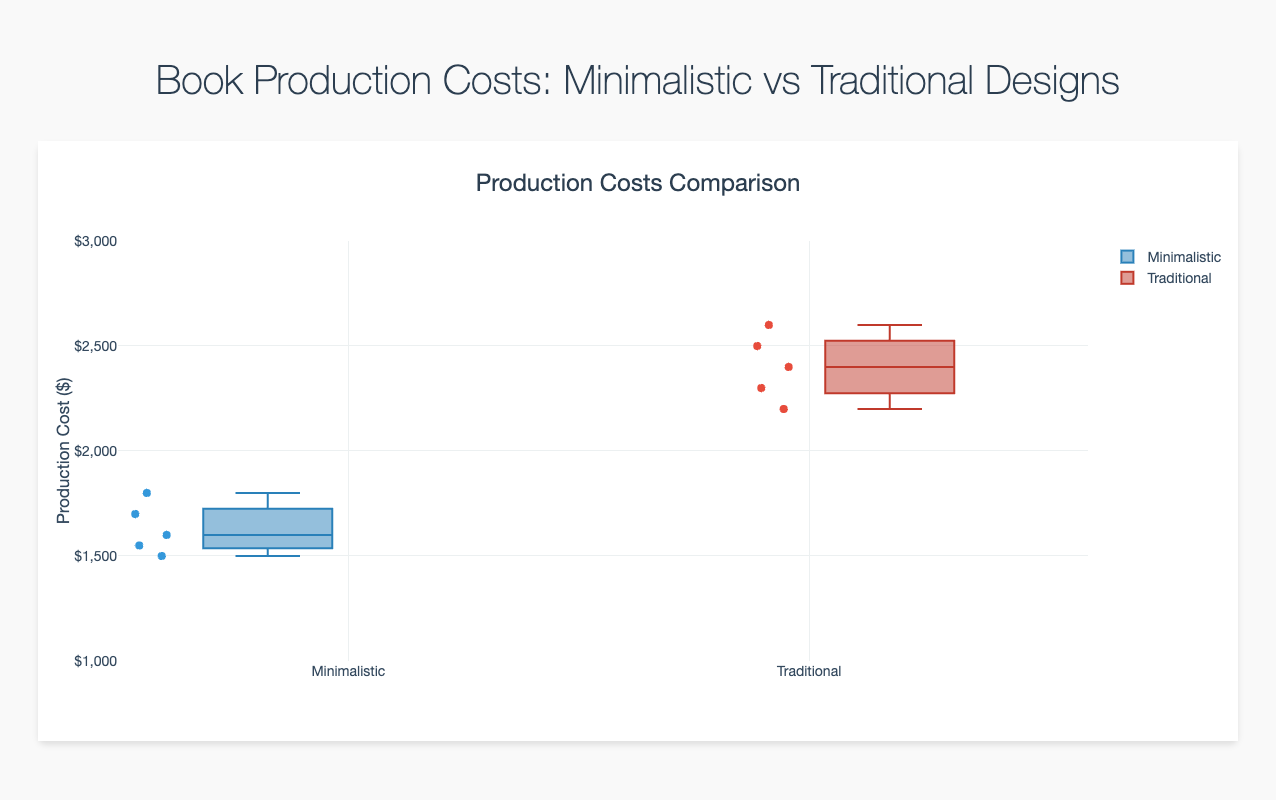What's the median production cost for books with minimalistic cover designs? The median value is the middle value when data points are arranged in ascending order. Arrange the minimalistic costs (1500, 1550, 1600, 1700, 1800), and the middle value is 1600.
Answer: 1600 Which design style has a higher maximum production cost? Look at the highest points of the whiskers for both box plots. The highest point for minimalistic is 1800, and for traditional, it is 2600.
Answer: Traditional How many data points are there for books with minimalistic cover designs? Count the number of points present in the "Minimalistic" box plot. There are 5 points shown.
Answer: 5 What is the interquartile range (IQR) for books with traditional cover designs? The IQR is the difference between the 75th percentile and the 25th percentile. For traditional designs, this range appears to be from around 2300 to 2400 (approximated from the box plot edges). So, 2400 - 2300 = 100.
Answer: 100 Which design style shows a wider spread in production costs? The spread can be observed by looking at the range from the minimum to maximum values in the box plot. Minimalistic ranges from 1500 to 1800 (300), while traditional ranges from 2200 to 2600 (400).
Answer: Traditional Is there any overlap in production costs between the two design styles? Check if any part of the minimalistic whiskers overlaps with the traditional box or whiskers. Minimalistic goes up to 1800 and traditional starts from 2200; there is no overlap.
Answer: No What is the minimum production cost for books with traditional cover designs? The minimum value for the traditional box plot is the lower whisker endpoint, which is approximately 2200.
Answer: 2200 Which design style has a lower median production cost? Compare the median values (middle lines in the boxes). Minimalistic's median is 1600, while traditional's median is around 2400.
Answer: Minimalistic How does the overall variability in production costs compare between the two design styles? Analyze the range of the data, the size of the boxes (IQR), and presence of outliers. Traditional has higher ranges and a wider IQR indicating more variability.
Answer: Traditional What is the median production cost for books with traditional cover designs? From the box plot, the median (line within the box) for traditional designs is approximately 2400.
Answer: 2400 